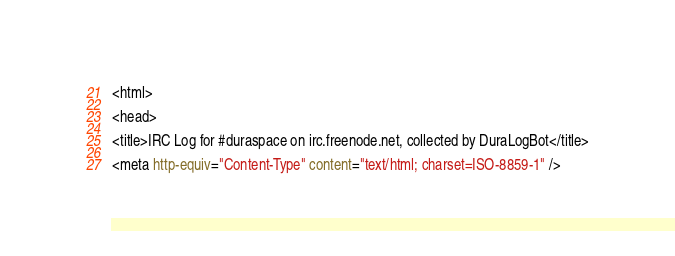Convert code to text. <code><loc_0><loc_0><loc_500><loc_500><_HTML_><html>

<head>

<title>IRC Log for #duraspace on irc.freenode.net, collected by DuraLogBot</title>

<meta http-equiv="Content-Type" content="text/html; charset=ISO-8859-1" /></code> 